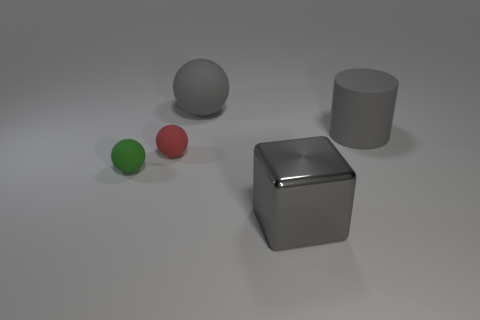Are there any other things that have the same material as the gray block?
Offer a very short reply. No. How many other things are the same shape as the metal object?
Your answer should be compact. 0. What number of red objects are large spheres or tiny balls?
Give a very brief answer. 1. Does the metal object that is on the right side of the tiny red thing have the same color as the large rubber ball?
Make the answer very short. Yes. The tiny thing that is the same material as the green sphere is what shape?
Your answer should be very brief. Sphere. The rubber thing that is on the left side of the gray metallic thing and behind the red rubber object is what color?
Provide a short and direct response. Gray. There is a red ball that is right of the small rubber thing that is left of the red matte ball; what is its size?
Give a very brief answer. Small. Is there a cylinder of the same color as the large sphere?
Keep it short and to the point. Yes. Is the number of tiny green objects to the right of the small green ball the same as the number of small yellow rubber cubes?
Give a very brief answer. Yes. What number of objects are there?
Make the answer very short. 5. 